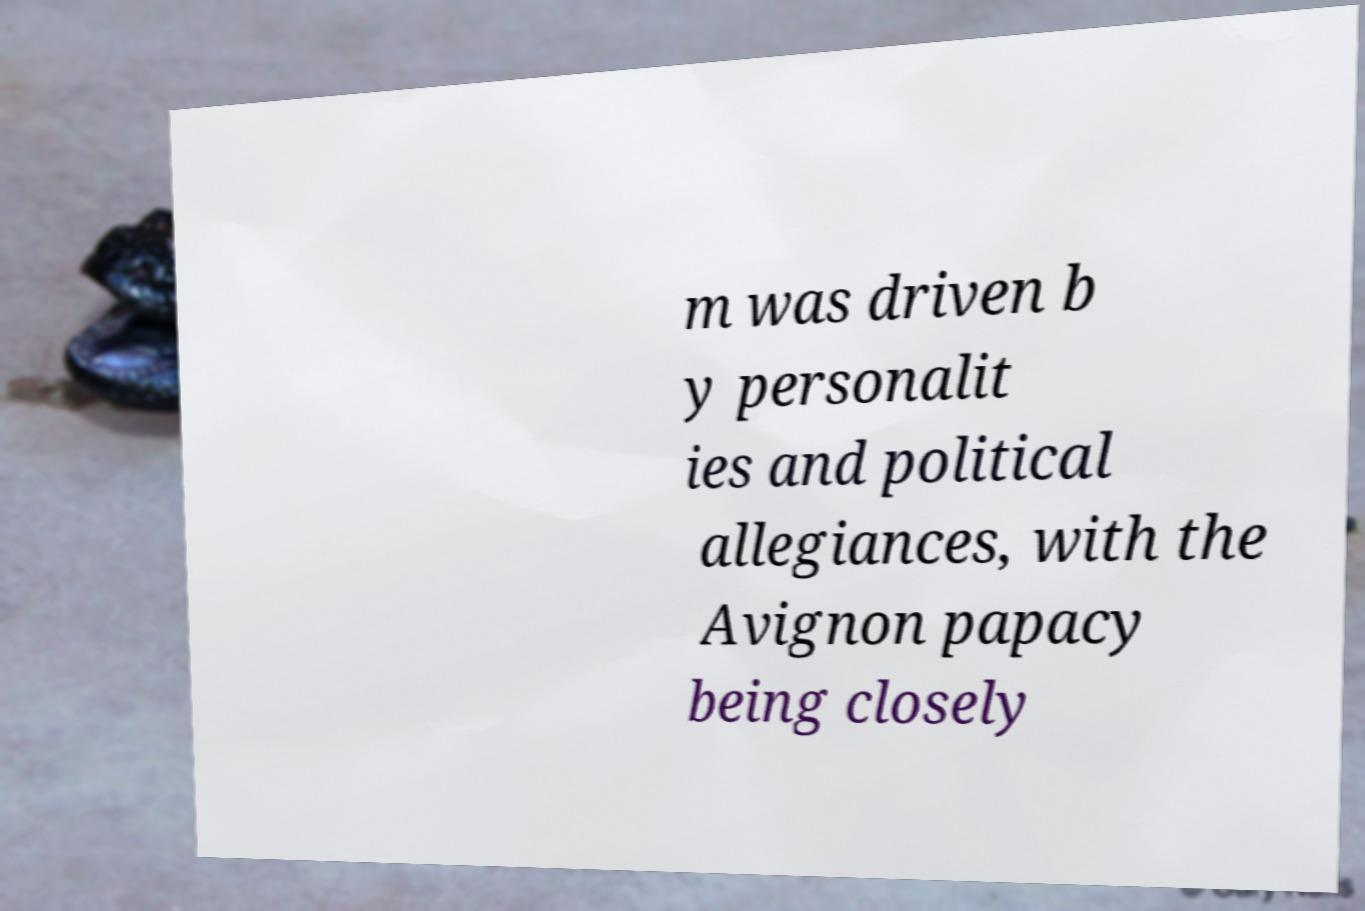Could you extract and type out the text from this image? m was driven b y personalit ies and political allegiances, with the Avignon papacy being closely 